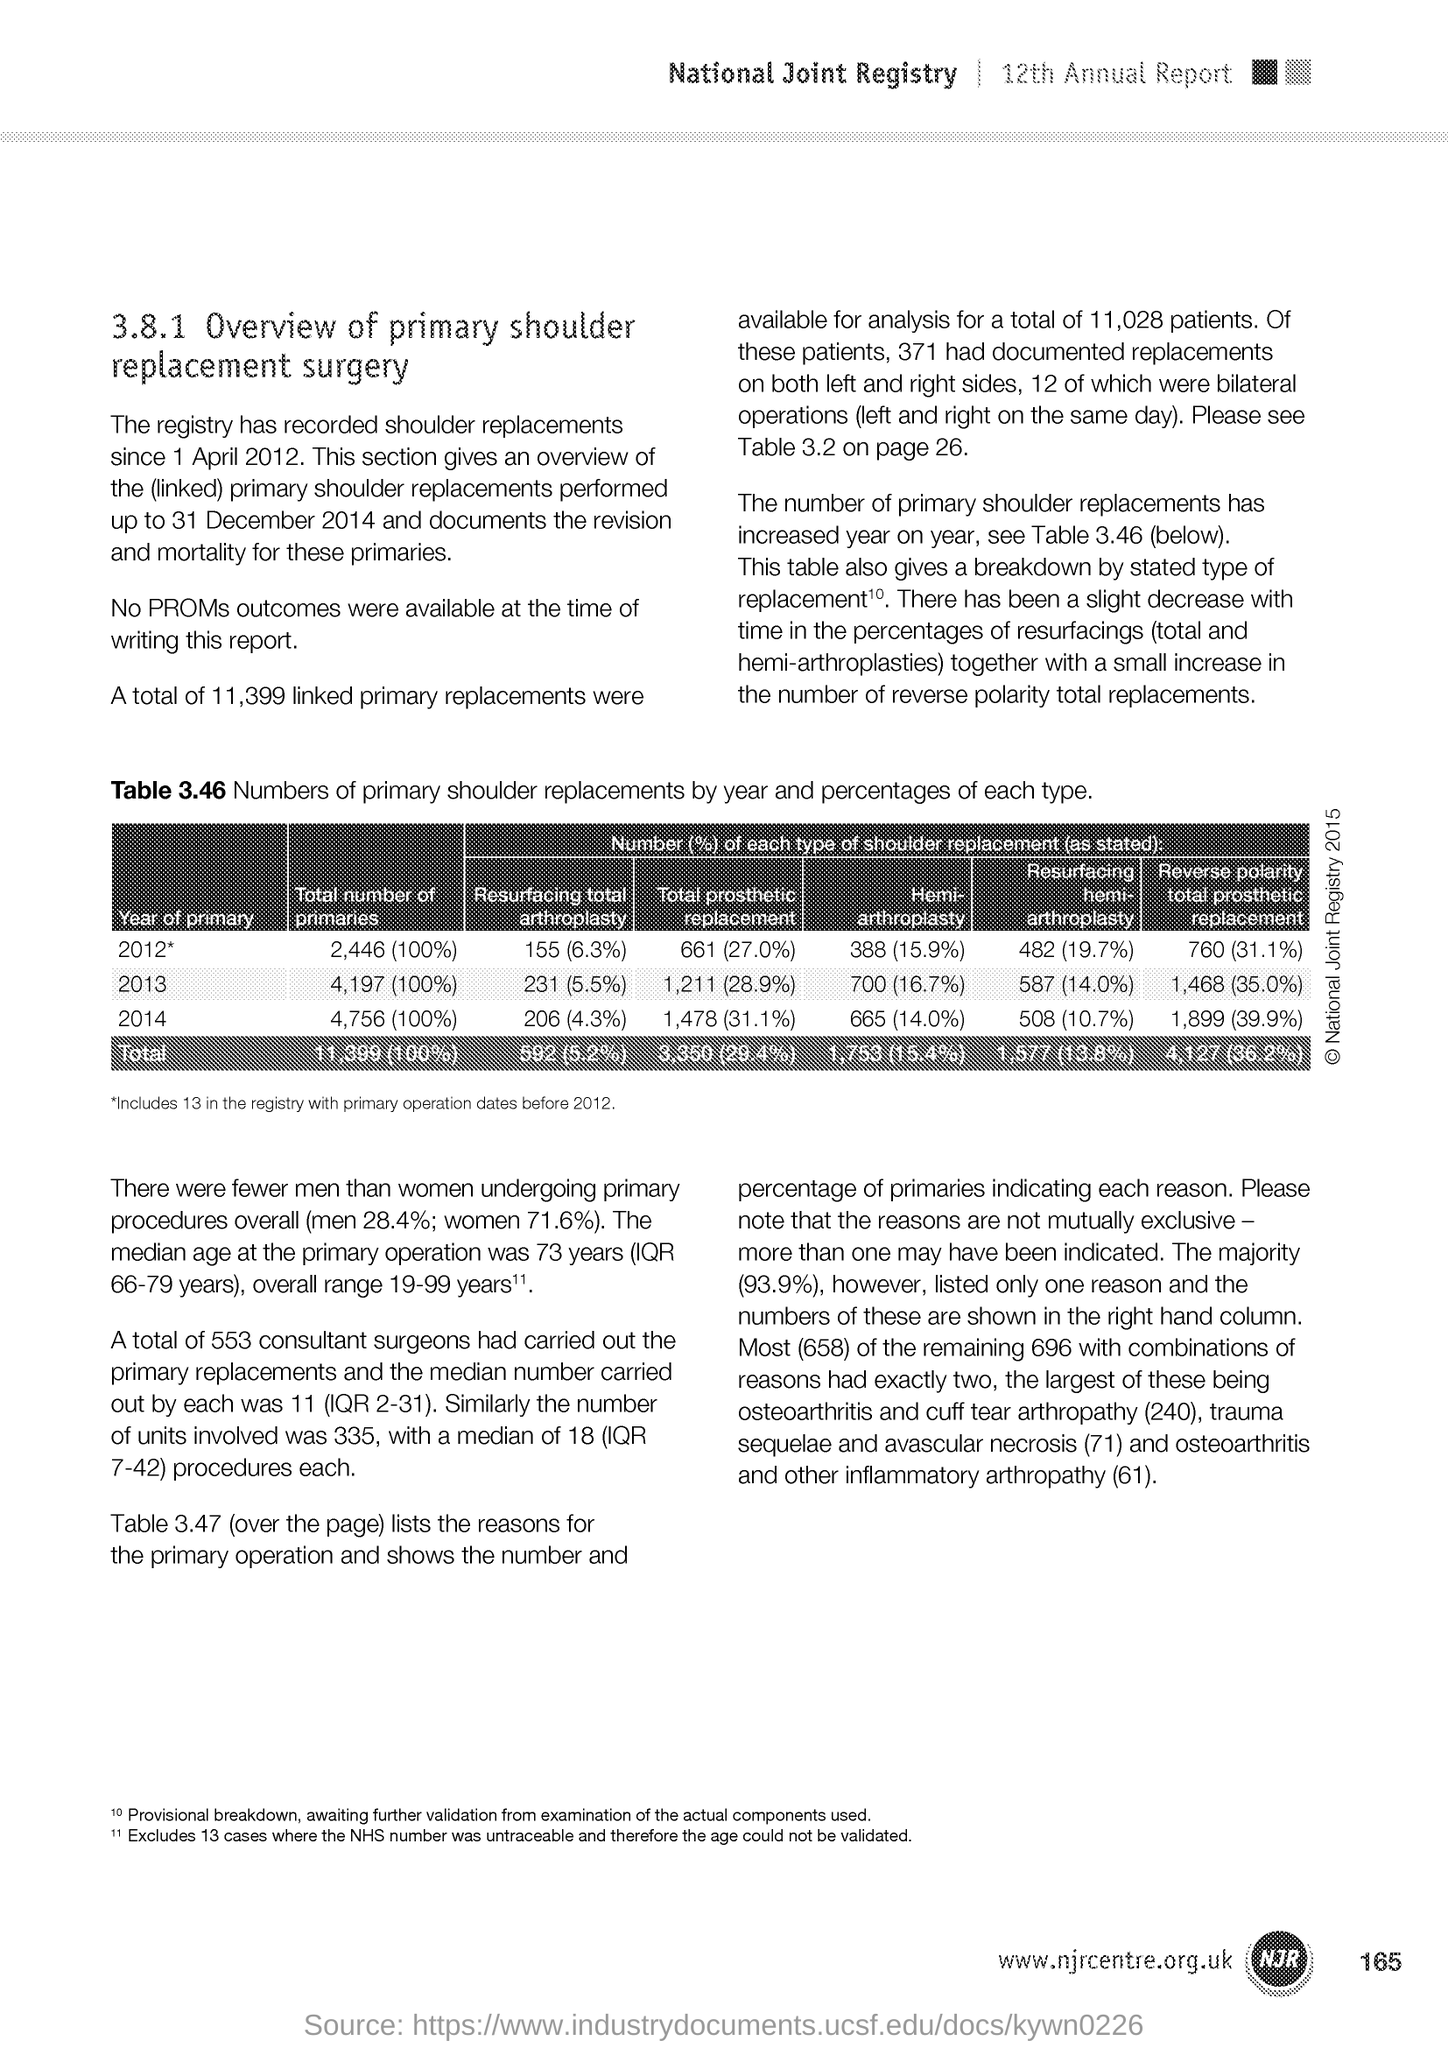Specify some key components in this picture. The document mentions the 12th Annual Report. 